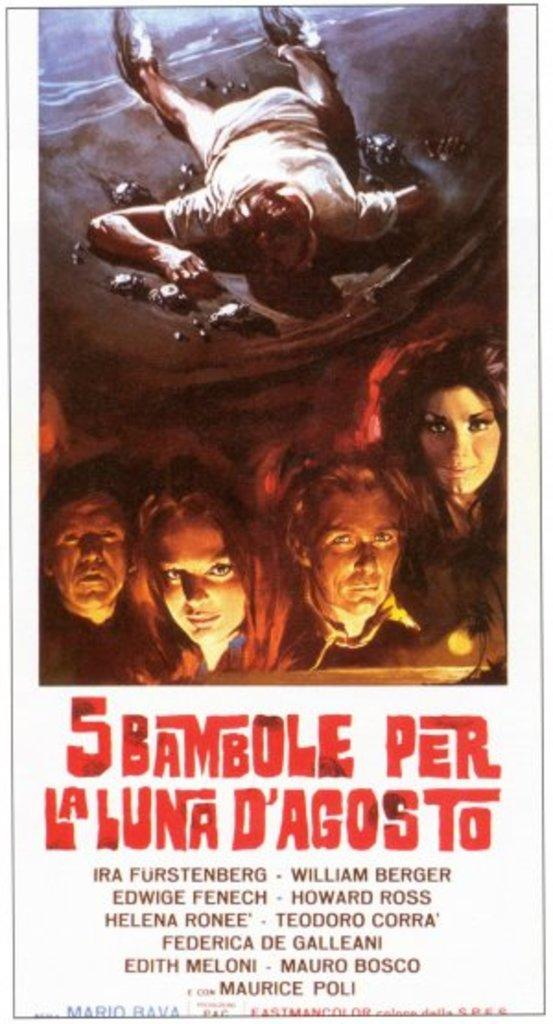Provide a one-sentence caption for the provided image. A movie poster is shown for 5 Bambole Per La Luna D'Agosto. 